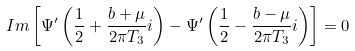Convert formula to latex. <formula><loc_0><loc_0><loc_500><loc_500>I m \left [ \Psi ^ { \prime } \left ( \frac { 1 } { 2 } + \frac { b + \mu } { 2 \pi T _ { 3 } } i \right ) - \Psi ^ { \prime } \left ( \frac { 1 } { 2 } - \frac { b - \mu } { 2 \pi T _ { 3 } } i \right ) \right ] = 0</formula> 